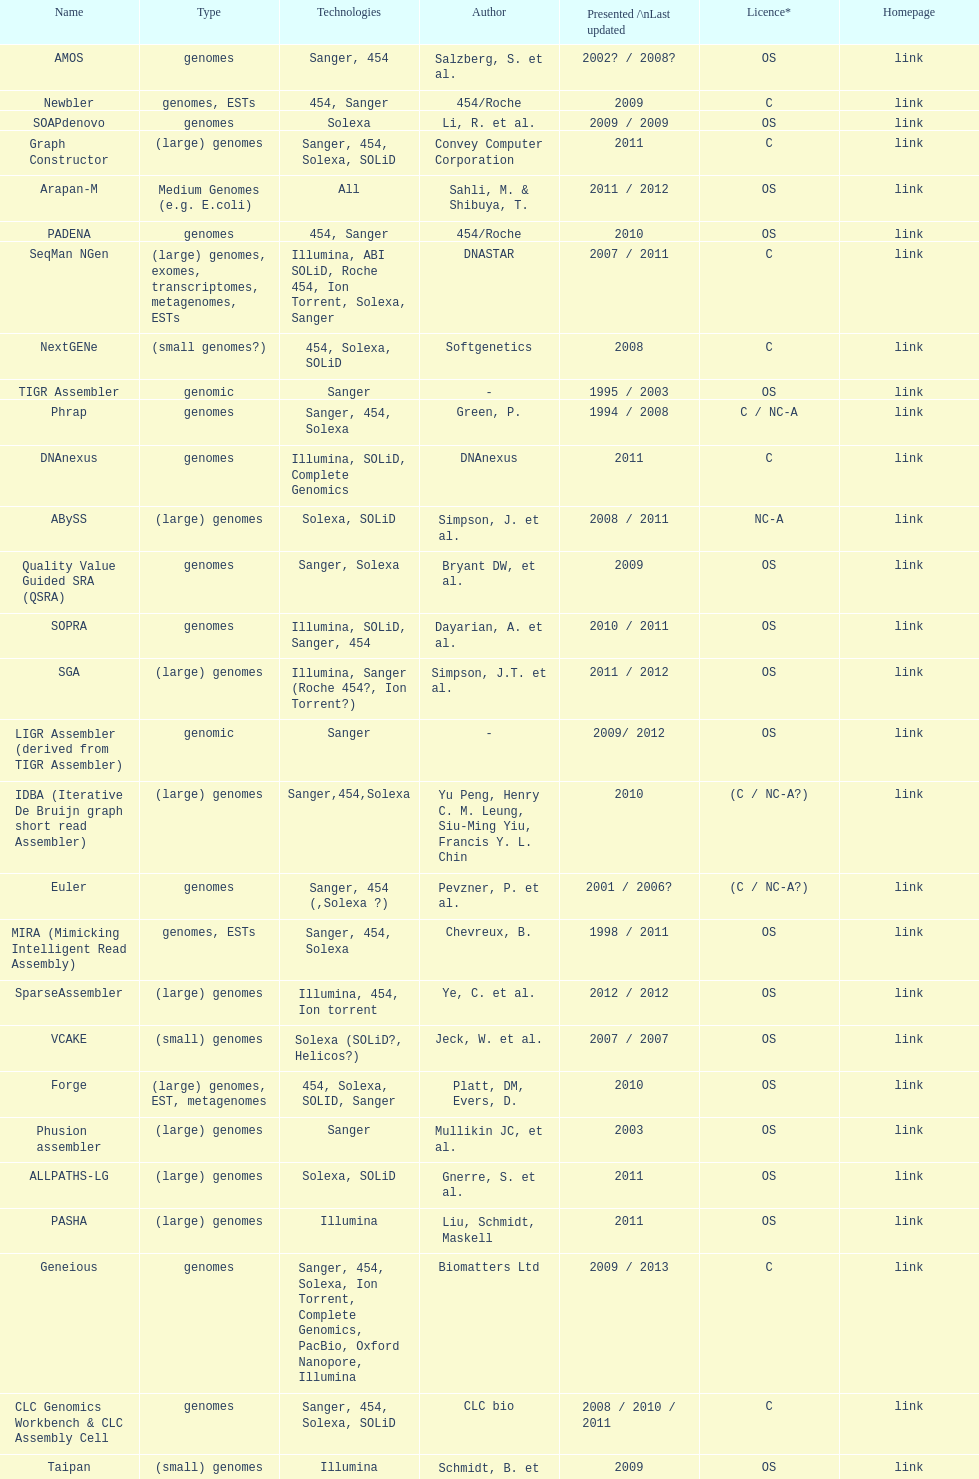When was the velvet last updated? 2009. Give me the full table as a dictionary. {'header': ['Name', 'Type', 'Technologies', 'Author', 'Presented /\\nLast updated', 'Licence*', 'Homepage'], 'rows': [['AMOS', 'genomes', 'Sanger, 454', 'Salzberg, S. et al.', '2002? / 2008?', 'OS', 'link'], ['Newbler', 'genomes, ESTs', '454, Sanger', '454/Roche', '2009', 'C', 'link'], ['SOAPdenovo', 'genomes', 'Solexa', 'Li, R. et al.', '2009 / 2009', 'OS', 'link'], ['Graph Constructor', '(large) genomes', 'Sanger, 454, Solexa, SOLiD', 'Convey Computer Corporation', '2011', 'C', 'link'], ['Arapan-M', 'Medium Genomes (e.g. E.coli)', 'All', 'Sahli, M. & Shibuya, T.', '2011 / 2012', 'OS', 'link'], ['PADENA', 'genomes', '454, Sanger', '454/Roche', '2010', 'OS', 'link'], ['SeqMan NGen', '(large) genomes, exomes, transcriptomes, metagenomes, ESTs', 'Illumina, ABI SOLiD, Roche 454, Ion Torrent, Solexa, Sanger', 'DNASTAR', '2007 / 2011', 'C', 'link'], ['NextGENe', '(small genomes?)', '454, Solexa, SOLiD', 'Softgenetics', '2008', 'C', 'link'], ['TIGR Assembler', 'genomic', 'Sanger', '-', '1995 / 2003', 'OS', 'link'], ['Phrap', 'genomes', 'Sanger, 454, Solexa', 'Green, P.', '1994 / 2008', 'C / NC-A', 'link'], ['DNAnexus', 'genomes', 'Illumina, SOLiD, Complete Genomics', 'DNAnexus', '2011', 'C', 'link'], ['ABySS', '(large) genomes', 'Solexa, SOLiD', 'Simpson, J. et al.', '2008 / 2011', 'NC-A', 'link'], ['Quality Value Guided SRA (QSRA)', 'genomes', 'Sanger, Solexa', 'Bryant DW, et al.', '2009', 'OS', 'link'], ['SOPRA', 'genomes', 'Illumina, SOLiD, Sanger, 454', 'Dayarian, A. et al.', '2010 / 2011', 'OS', 'link'], ['SGA', '(large) genomes', 'Illumina, Sanger (Roche 454?, Ion Torrent?)', 'Simpson, J.T. et al.', '2011 / 2012', 'OS', 'link'], ['LIGR Assembler (derived from TIGR Assembler)', 'genomic', 'Sanger', '-', '2009/ 2012', 'OS', 'link'], ['IDBA (Iterative De Bruijn graph short read Assembler)', '(large) genomes', 'Sanger,454,Solexa', 'Yu Peng, Henry C. M. Leung, Siu-Ming Yiu, Francis Y. L. Chin', '2010', '(C / NC-A?)', 'link'], ['Euler', 'genomes', 'Sanger, 454 (,Solexa\xa0?)', 'Pevzner, P. et al.', '2001 / 2006?', '(C / NC-A?)', 'link'], ['MIRA (Mimicking Intelligent Read Assembly)', 'genomes, ESTs', 'Sanger, 454, Solexa', 'Chevreux, B.', '1998 / 2011', 'OS', 'link'], ['SparseAssembler', '(large) genomes', 'Illumina, 454, Ion torrent', 'Ye, C. et al.', '2012 / 2012', 'OS', 'link'], ['VCAKE', '(small) genomes', 'Solexa (SOLiD?, Helicos?)', 'Jeck, W. et al.', '2007 / 2007', 'OS', 'link'], ['Forge', '(large) genomes, EST, metagenomes', '454, Solexa, SOLID, Sanger', 'Platt, DM, Evers, D.', '2010', 'OS', 'link'], ['Phusion assembler', '(large) genomes', 'Sanger', 'Mullikin JC, et al.', '2003', 'OS', 'link'], ['ALLPATHS-LG', '(large) genomes', 'Solexa, SOLiD', 'Gnerre, S. et al.', '2011', 'OS', 'link'], ['PASHA', '(large) genomes', 'Illumina', 'Liu, Schmidt, Maskell', '2011', 'OS', 'link'], ['Geneious', 'genomes', 'Sanger, 454, Solexa, Ion Torrent, Complete Genomics, PacBio, Oxford Nanopore, Illumina', 'Biomatters Ltd', '2009 / 2013', 'C', 'link'], ['CLC Genomics Workbench & CLC Assembly Cell', 'genomes', 'Sanger, 454, Solexa, SOLiD', 'CLC bio', '2008 / 2010 / 2011', 'C', 'link'], ['Taipan', '(small) genomes', 'Illumina', 'Schmidt, B. et al.', '2009', 'OS', 'link'], ['SPAdes', '(small) genomes, single-cell', 'Illumina, Solexa', 'Bankevich, A et al.', '2012 / 2013', 'OS', 'link'], ['Ray', 'genomes', 'Illumina, mix of Illumina and 454, paired or not', 'Sébastien Boisvert, François Laviolette & Jacques Corbeil.', '2010', 'OS [GNU General Public License]', 'link'], ['Edena', 'genomes', 'Illumina', 'D. Hernandez, P. François, L. Farinelli, M. Osteras, and J. Schrenzel.', '2008/2013', 'OS', 'link'], ['DNA Baser', 'genomes', 'Sanger, 454', 'Heracle BioSoft SRL', '01.2014', 'C', 'www.DnaBaser.com'], ['SHARCGS', '(small) genomes', 'Solexa', 'Dohm et al.', '2007 / 2007', 'OS', 'link'], ['Arapan-S', 'Small Genomes (Viruses and Bacteria)', 'All', 'Sahli, M. & Shibuya, T.', '2011 / 2012', 'OS', 'link'], ['Velvet', '(small) genomes', 'Sanger, 454, Solexa, SOLiD', 'Zerbino, D. et al.', '2007 / 2009', 'OS', 'link'], ['DNA Dragon', 'genomes', 'Illumina, SOLiD, Complete Genomics, 454, Sanger', 'SequentiX', '2011', 'C', 'link'], ['Staden gap4 package', 'BACs (, small genomes?)', 'Sanger', 'Staden et al.', '1991 / 2008', 'OS', 'link'], ['Euler-sr', 'genomes', '454, Solexa', 'Chaisson, MJ. et al.', '2008', 'NC-A', 'link'], ['Celera WGA Assembler / CABOG', '(large) genomes', 'Sanger, 454, Solexa', 'Myers, G. et al.; Miller G. et al.', '2004 / 2010', 'OS', 'link'], ['Cortex', 'genomes', 'Solexa, SOLiD', 'Iqbal, Z. et al.', '2011', 'OS', 'link'], ['Sequencher', 'genomes', 'traditional and next generation sequence data', 'Gene Codes Corporation', '1991 / 2009 / 2011', 'C', 'link'], ['SSAKE', '(small) genomes', 'Solexa (SOLiD? Helicos?)', 'Warren, R. et al.', '2007 / 2007', 'OS', 'link'], ['MaSuRCA (Maryland Super Read - Celera Assembler)', '(large) genomes', 'Sanger, Illumina, 454', 'Aleksey Zimin, Guillaume Marçais, Daniela Puiu, Michael Roberts, Steven L. Salzberg, James A. Yorke', '2012 / 2013', 'OS', 'link']]} 